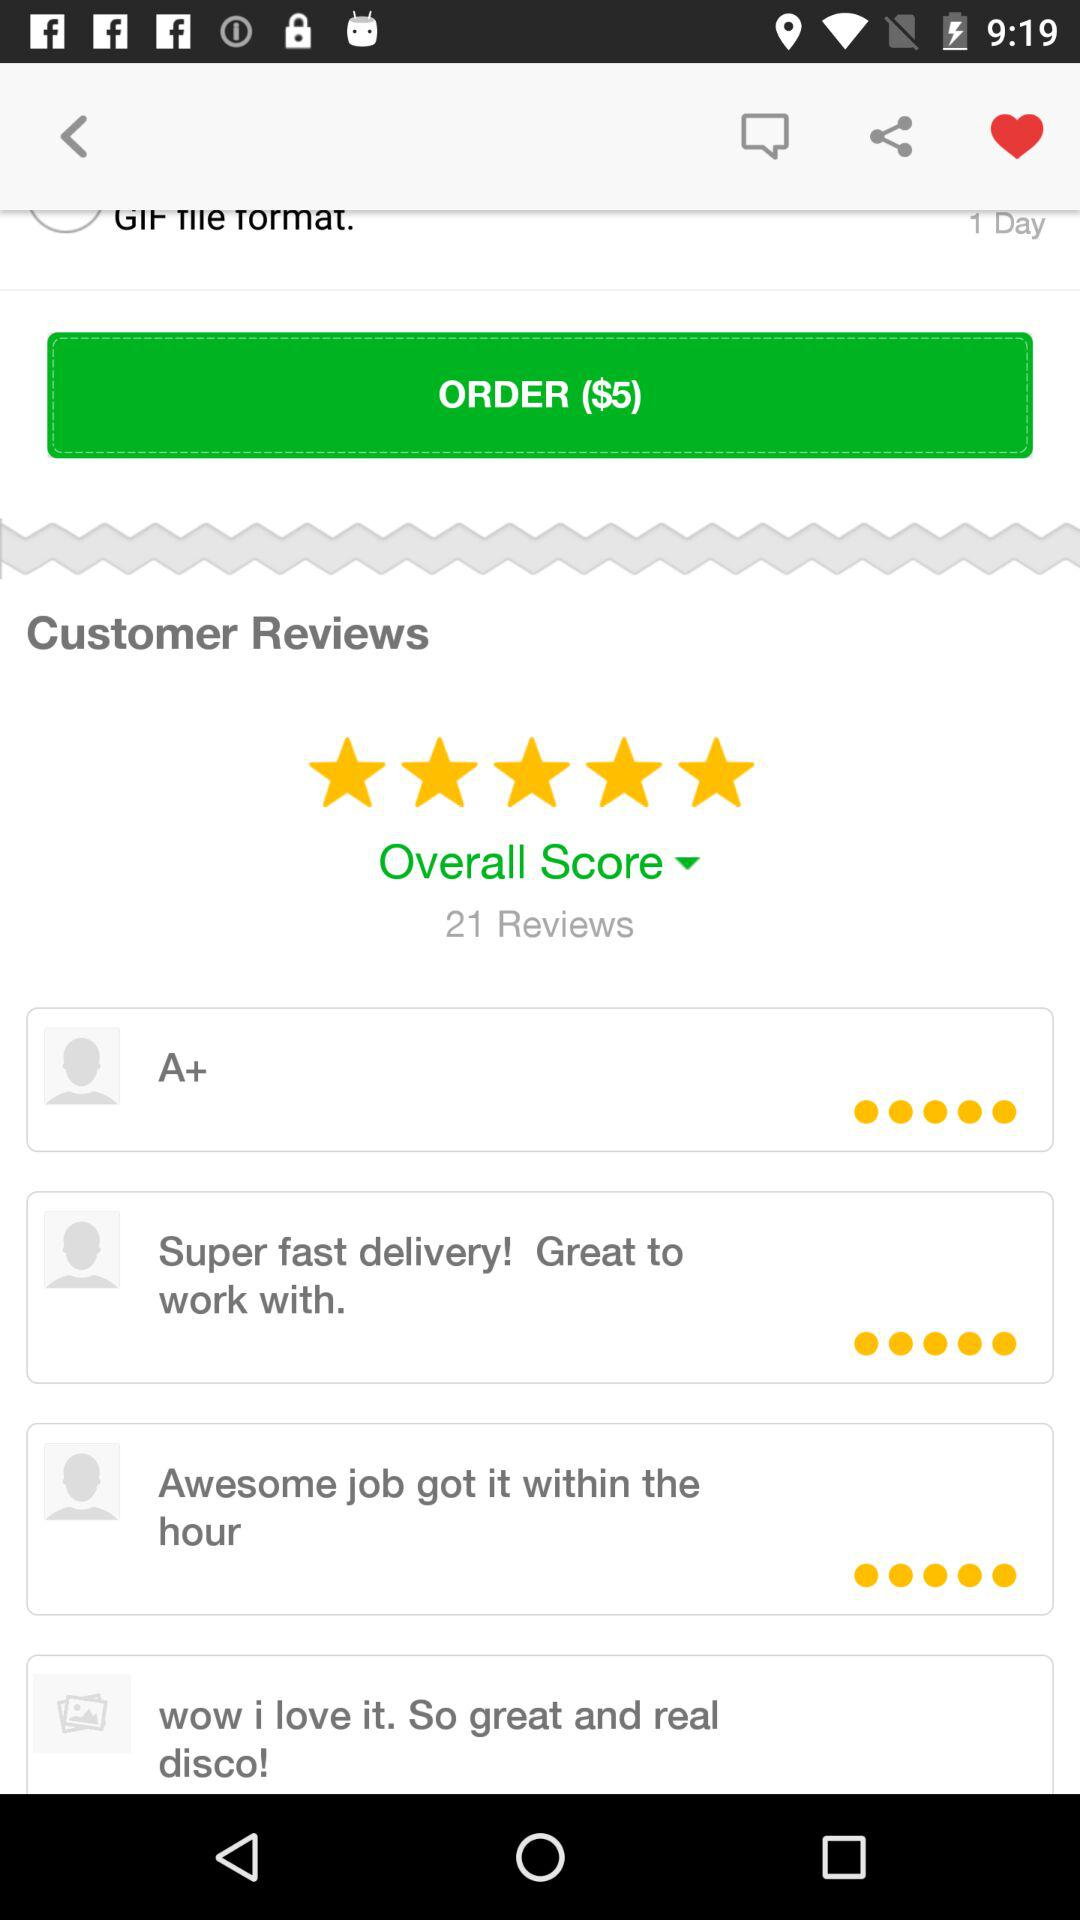How many unread messages are there?
When the provided information is insufficient, respond with <no answer>. <no answer> 